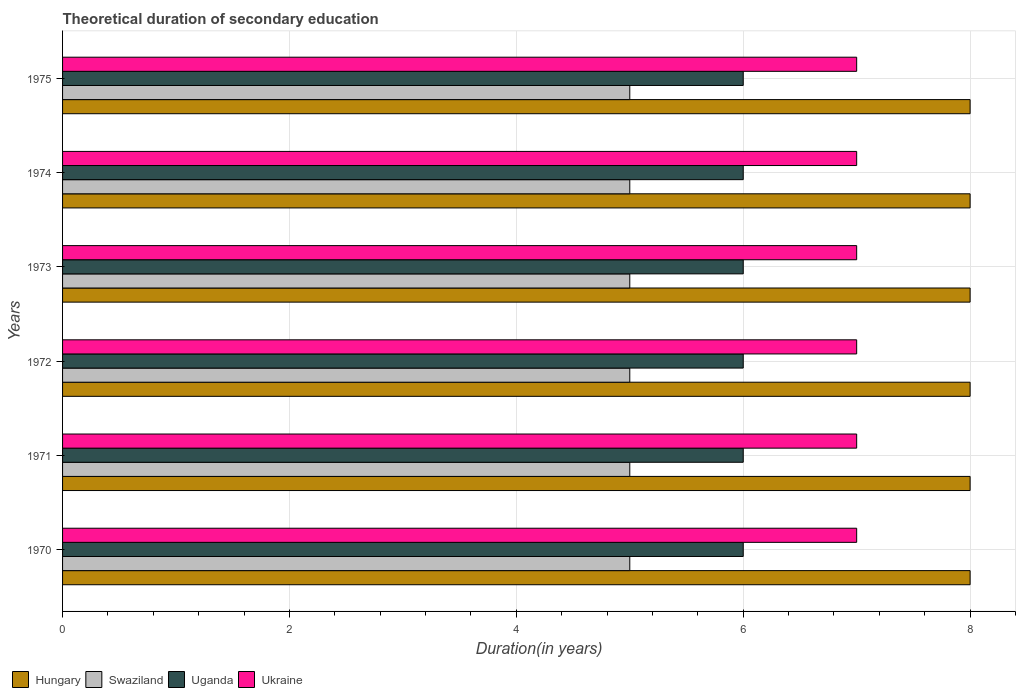How many groups of bars are there?
Your answer should be compact. 6. How many bars are there on the 1st tick from the bottom?
Offer a very short reply. 4. What is the label of the 3rd group of bars from the top?
Make the answer very short. 1973. What is the total theoretical duration of secondary education in Hungary in 1970?
Keep it short and to the point. 8. Across all years, what is the maximum total theoretical duration of secondary education in Swaziland?
Your response must be concise. 5. Across all years, what is the minimum total theoretical duration of secondary education in Swaziland?
Make the answer very short. 5. In which year was the total theoretical duration of secondary education in Swaziland maximum?
Keep it short and to the point. 1970. In which year was the total theoretical duration of secondary education in Uganda minimum?
Keep it short and to the point. 1970. What is the total total theoretical duration of secondary education in Uganda in the graph?
Provide a succinct answer. 36. What is the difference between the total theoretical duration of secondary education in Uganda in 1971 and the total theoretical duration of secondary education in Ukraine in 1972?
Your answer should be compact. -1. In the year 1970, what is the difference between the total theoretical duration of secondary education in Hungary and total theoretical duration of secondary education in Swaziland?
Make the answer very short. 3. In how many years, is the total theoretical duration of secondary education in Swaziland greater than 1.2000000000000002 years?
Ensure brevity in your answer.  6. What is the difference between the highest and the second highest total theoretical duration of secondary education in Swaziland?
Provide a succinct answer. 0. What is the difference between the highest and the lowest total theoretical duration of secondary education in Swaziland?
Your answer should be compact. 0. What does the 1st bar from the top in 1973 represents?
Offer a very short reply. Ukraine. What does the 4th bar from the bottom in 1973 represents?
Offer a very short reply. Ukraine. Are all the bars in the graph horizontal?
Make the answer very short. Yes. How many years are there in the graph?
Your answer should be compact. 6. What is the difference between two consecutive major ticks on the X-axis?
Your response must be concise. 2. Does the graph contain any zero values?
Provide a succinct answer. No. Where does the legend appear in the graph?
Provide a short and direct response. Bottom left. What is the title of the graph?
Offer a terse response. Theoretical duration of secondary education. Does "Morocco" appear as one of the legend labels in the graph?
Your answer should be compact. No. What is the label or title of the X-axis?
Make the answer very short. Duration(in years). What is the Duration(in years) in Hungary in 1970?
Provide a short and direct response. 8. What is the Duration(in years) in Swaziland in 1970?
Your answer should be compact. 5. What is the Duration(in years) in Ukraine in 1970?
Your answer should be compact. 7. What is the Duration(in years) of Hungary in 1971?
Your answer should be compact. 8. What is the Duration(in years) in Ukraine in 1971?
Ensure brevity in your answer.  7. What is the Duration(in years) of Uganda in 1972?
Ensure brevity in your answer.  6. What is the Duration(in years) of Swaziland in 1973?
Provide a succinct answer. 5. What is the Duration(in years) in Uganda in 1973?
Offer a very short reply. 6. What is the Duration(in years) in Hungary in 1974?
Offer a very short reply. 8. What is the Duration(in years) in Uganda in 1974?
Make the answer very short. 6. What is the Duration(in years) in Hungary in 1975?
Ensure brevity in your answer.  8. What is the Duration(in years) of Uganda in 1975?
Make the answer very short. 6. Across all years, what is the maximum Duration(in years) of Hungary?
Provide a succinct answer. 8. Across all years, what is the minimum Duration(in years) in Swaziland?
Your answer should be very brief. 5. Across all years, what is the minimum Duration(in years) of Uganda?
Keep it short and to the point. 6. What is the total Duration(in years) of Hungary in the graph?
Provide a short and direct response. 48. What is the total Duration(in years) in Uganda in the graph?
Your answer should be compact. 36. What is the total Duration(in years) of Ukraine in the graph?
Provide a short and direct response. 42. What is the difference between the Duration(in years) of Hungary in 1970 and that in 1971?
Give a very brief answer. 0. What is the difference between the Duration(in years) of Hungary in 1970 and that in 1972?
Offer a very short reply. 0. What is the difference between the Duration(in years) in Swaziland in 1970 and that in 1972?
Provide a succinct answer. 0. What is the difference between the Duration(in years) in Ukraine in 1970 and that in 1972?
Keep it short and to the point. 0. What is the difference between the Duration(in years) in Hungary in 1970 and that in 1973?
Your answer should be compact. 0. What is the difference between the Duration(in years) in Swaziland in 1970 and that in 1973?
Your answer should be compact. 0. What is the difference between the Duration(in years) in Uganda in 1970 and that in 1973?
Provide a succinct answer. 0. What is the difference between the Duration(in years) of Ukraine in 1970 and that in 1973?
Your answer should be very brief. 0. What is the difference between the Duration(in years) of Hungary in 1970 and that in 1974?
Provide a short and direct response. 0. What is the difference between the Duration(in years) in Swaziland in 1970 and that in 1974?
Your answer should be very brief. 0. What is the difference between the Duration(in years) of Uganda in 1970 and that in 1974?
Ensure brevity in your answer.  0. What is the difference between the Duration(in years) in Hungary in 1971 and that in 1972?
Offer a very short reply. 0. What is the difference between the Duration(in years) of Hungary in 1971 and that in 1973?
Keep it short and to the point. 0. What is the difference between the Duration(in years) of Swaziland in 1971 and that in 1973?
Give a very brief answer. 0. What is the difference between the Duration(in years) of Uganda in 1971 and that in 1973?
Ensure brevity in your answer.  0. What is the difference between the Duration(in years) in Hungary in 1971 and that in 1974?
Provide a succinct answer. 0. What is the difference between the Duration(in years) in Swaziland in 1971 and that in 1974?
Give a very brief answer. 0. What is the difference between the Duration(in years) in Uganda in 1971 and that in 1974?
Ensure brevity in your answer.  0. What is the difference between the Duration(in years) of Ukraine in 1971 and that in 1974?
Give a very brief answer. 0. What is the difference between the Duration(in years) in Uganda in 1972 and that in 1973?
Make the answer very short. 0. What is the difference between the Duration(in years) of Uganda in 1972 and that in 1974?
Make the answer very short. 0. What is the difference between the Duration(in years) in Hungary in 1972 and that in 1975?
Offer a terse response. 0. What is the difference between the Duration(in years) in Swaziland in 1972 and that in 1975?
Give a very brief answer. 0. What is the difference between the Duration(in years) in Uganda in 1972 and that in 1975?
Ensure brevity in your answer.  0. What is the difference between the Duration(in years) of Hungary in 1973 and that in 1974?
Your response must be concise. 0. What is the difference between the Duration(in years) of Swaziland in 1973 and that in 1974?
Provide a succinct answer. 0. What is the difference between the Duration(in years) in Uganda in 1973 and that in 1974?
Offer a very short reply. 0. What is the difference between the Duration(in years) in Hungary in 1973 and that in 1975?
Give a very brief answer. 0. What is the difference between the Duration(in years) in Swaziland in 1973 and that in 1975?
Offer a very short reply. 0. What is the difference between the Duration(in years) in Uganda in 1973 and that in 1975?
Provide a succinct answer. 0. What is the difference between the Duration(in years) of Ukraine in 1973 and that in 1975?
Your answer should be very brief. 0. What is the difference between the Duration(in years) in Swaziland in 1974 and that in 1975?
Provide a succinct answer. 0. What is the difference between the Duration(in years) in Uganda in 1974 and that in 1975?
Your answer should be very brief. 0. What is the difference between the Duration(in years) of Hungary in 1970 and the Duration(in years) of Swaziland in 1971?
Your answer should be very brief. 3. What is the difference between the Duration(in years) in Hungary in 1970 and the Duration(in years) in Uganda in 1971?
Keep it short and to the point. 2. What is the difference between the Duration(in years) of Hungary in 1970 and the Duration(in years) of Ukraine in 1971?
Provide a short and direct response. 1. What is the difference between the Duration(in years) in Swaziland in 1970 and the Duration(in years) in Uganda in 1971?
Your response must be concise. -1. What is the difference between the Duration(in years) of Swaziland in 1970 and the Duration(in years) of Ukraine in 1971?
Your answer should be very brief. -2. What is the difference between the Duration(in years) in Hungary in 1970 and the Duration(in years) in Swaziland in 1972?
Your response must be concise. 3. What is the difference between the Duration(in years) in Hungary in 1970 and the Duration(in years) in Ukraine in 1972?
Your answer should be very brief. 1. What is the difference between the Duration(in years) in Swaziland in 1970 and the Duration(in years) in Uganda in 1972?
Keep it short and to the point. -1. What is the difference between the Duration(in years) in Uganda in 1970 and the Duration(in years) in Ukraine in 1972?
Offer a terse response. -1. What is the difference between the Duration(in years) of Hungary in 1970 and the Duration(in years) of Uganda in 1973?
Ensure brevity in your answer.  2. What is the difference between the Duration(in years) of Hungary in 1970 and the Duration(in years) of Swaziland in 1974?
Offer a very short reply. 3. What is the difference between the Duration(in years) of Hungary in 1970 and the Duration(in years) of Uganda in 1974?
Your answer should be compact. 2. What is the difference between the Duration(in years) in Swaziland in 1970 and the Duration(in years) in Uganda in 1974?
Ensure brevity in your answer.  -1. What is the difference between the Duration(in years) of Hungary in 1970 and the Duration(in years) of Swaziland in 1975?
Your response must be concise. 3. What is the difference between the Duration(in years) of Hungary in 1970 and the Duration(in years) of Ukraine in 1975?
Offer a terse response. 1. What is the difference between the Duration(in years) of Hungary in 1971 and the Duration(in years) of Swaziland in 1972?
Keep it short and to the point. 3. What is the difference between the Duration(in years) in Swaziland in 1971 and the Duration(in years) in Ukraine in 1973?
Make the answer very short. -2. What is the difference between the Duration(in years) of Uganda in 1971 and the Duration(in years) of Ukraine in 1973?
Offer a terse response. -1. What is the difference between the Duration(in years) in Swaziland in 1971 and the Duration(in years) in Uganda in 1974?
Ensure brevity in your answer.  -1. What is the difference between the Duration(in years) of Uganda in 1971 and the Duration(in years) of Ukraine in 1974?
Your response must be concise. -1. What is the difference between the Duration(in years) in Hungary in 1971 and the Duration(in years) in Ukraine in 1975?
Offer a very short reply. 1. What is the difference between the Duration(in years) in Uganda in 1971 and the Duration(in years) in Ukraine in 1975?
Offer a terse response. -1. What is the difference between the Duration(in years) in Hungary in 1972 and the Duration(in years) in Uganda in 1973?
Ensure brevity in your answer.  2. What is the difference between the Duration(in years) of Swaziland in 1972 and the Duration(in years) of Uganda in 1973?
Your answer should be compact. -1. What is the difference between the Duration(in years) of Uganda in 1972 and the Duration(in years) of Ukraine in 1973?
Your response must be concise. -1. What is the difference between the Duration(in years) of Hungary in 1972 and the Duration(in years) of Uganda in 1974?
Your answer should be compact. 2. What is the difference between the Duration(in years) of Hungary in 1972 and the Duration(in years) of Ukraine in 1974?
Your response must be concise. 1. What is the difference between the Duration(in years) of Uganda in 1972 and the Duration(in years) of Ukraine in 1974?
Your answer should be compact. -1. What is the difference between the Duration(in years) in Hungary in 1972 and the Duration(in years) in Ukraine in 1975?
Provide a succinct answer. 1. What is the difference between the Duration(in years) in Hungary in 1973 and the Duration(in years) in Ukraine in 1974?
Provide a short and direct response. 1. What is the difference between the Duration(in years) in Uganda in 1973 and the Duration(in years) in Ukraine in 1974?
Provide a succinct answer. -1. What is the difference between the Duration(in years) of Hungary in 1973 and the Duration(in years) of Swaziland in 1975?
Ensure brevity in your answer.  3. What is the difference between the Duration(in years) in Hungary in 1973 and the Duration(in years) in Uganda in 1975?
Keep it short and to the point. 2. What is the difference between the Duration(in years) in Hungary in 1973 and the Duration(in years) in Ukraine in 1975?
Make the answer very short. 1. What is the difference between the Duration(in years) in Swaziland in 1973 and the Duration(in years) in Uganda in 1975?
Your answer should be compact. -1. What is the difference between the Duration(in years) of Hungary in 1974 and the Duration(in years) of Swaziland in 1975?
Offer a very short reply. 3. What is the difference between the Duration(in years) of Hungary in 1974 and the Duration(in years) of Ukraine in 1975?
Your answer should be very brief. 1. What is the difference between the Duration(in years) in Swaziland in 1974 and the Duration(in years) in Ukraine in 1975?
Your answer should be very brief. -2. What is the average Duration(in years) in Hungary per year?
Provide a succinct answer. 8. What is the average Duration(in years) of Uganda per year?
Your response must be concise. 6. In the year 1970, what is the difference between the Duration(in years) of Hungary and Duration(in years) of Swaziland?
Keep it short and to the point. 3. In the year 1970, what is the difference between the Duration(in years) in Hungary and Duration(in years) in Uganda?
Your response must be concise. 2. In the year 1970, what is the difference between the Duration(in years) in Hungary and Duration(in years) in Ukraine?
Your answer should be compact. 1. In the year 1970, what is the difference between the Duration(in years) of Swaziland and Duration(in years) of Ukraine?
Give a very brief answer. -2. In the year 1970, what is the difference between the Duration(in years) of Uganda and Duration(in years) of Ukraine?
Offer a terse response. -1. In the year 1971, what is the difference between the Duration(in years) of Hungary and Duration(in years) of Swaziland?
Give a very brief answer. 3. In the year 1971, what is the difference between the Duration(in years) in Hungary and Duration(in years) in Uganda?
Your response must be concise. 2. In the year 1971, what is the difference between the Duration(in years) of Uganda and Duration(in years) of Ukraine?
Ensure brevity in your answer.  -1. In the year 1972, what is the difference between the Duration(in years) in Hungary and Duration(in years) in Ukraine?
Your answer should be compact. 1. In the year 1972, what is the difference between the Duration(in years) in Swaziland and Duration(in years) in Ukraine?
Your answer should be very brief. -2. In the year 1972, what is the difference between the Duration(in years) of Uganda and Duration(in years) of Ukraine?
Give a very brief answer. -1. In the year 1973, what is the difference between the Duration(in years) in Hungary and Duration(in years) in Swaziland?
Ensure brevity in your answer.  3. In the year 1973, what is the difference between the Duration(in years) of Hungary and Duration(in years) of Uganda?
Offer a terse response. 2. In the year 1973, what is the difference between the Duration(in years) of Hungary and Duration(in years) of Ukraine?
Ensure brevity in your answer.  1. In the year 1973, what is the difference between the Duration(in years) in Swaziland and Duration(in years) in Uganda?
Offer a terse response. -1. In the year 1973, what is the difference between the Duration(in years) in Swaziland and Duration(in years) in Ukraine?
Offer a very short reply. -2. In the year 1973, what is the difference between the Duration(in years) in Uganda and Duration(in years) in Ukraine?
Provide a succinct answer. -1. In the year 1974, what is the difference between the Duration(in years) in Hungary and Duration(in years) in Swaziland?
Keep it short and to the point. 3. In the year 1974, what is the difference between the Duration(in years) in Hungary and Duration(in years) in Uganda?
Offer a terse response. 2. In the year 1974, what is the difference between the Duration(in years) of Hungary and Duration(in years) of Ukraine?
Your answer should be compact. 1. In the year 1974, what is the difference between the Duration(in years) of Swaziland and Duration(in years) of Uganda?
Ensure brevity in your answer.  -1. In the year 1974, what is the difference between the Duration(in years) of Uganda and Duration(in years) of Ukraine?
Keep it short and to the point. -1. In the year 1975, what is the difference between the Duration(in years) of Hungary and Duration(in years) of Ukraine?
Offer a very short reply. 1. In the year 1975, what is the difference between the Duration(in years) in Swaziland and Duration(in years) in Uganda?
Ensure brevity in your answer.  -1. In the year 1975, what is the difference between the Duration(in years) of Uganda and Duration(in years) of Ukraine?
Offer a very short reply. -1. What is the ratio of the Duration(in years) in Hungary in 1970 to that in 1971?
Keep it short and to the point. 1. What is the ratio of the Duration(in years) in Uganda in 1970 to that in 1971?
Your response must be concise. 1. What is the ratio of the Duration(in years) in Swaziland in 1970 to that in 1972?
Keep it short and to the point. 1. What is the ratio of the Duration(in years) of Uganda in 1970 to that in 1972?
Provide a succinct answer. 1. What is the ratio of the Duration(in years) in Ukraine in 1970 to that in 1972?
Offer a terse response. 1. What is the ratio of the Duration(in years) of Hungary in 1970 to that in 1974?
Your answer should be very brief. 1. What is the ratio of the Duration(in years) in Hungary in 1970 to that in 1975?
Your response must be concise. 1. What is the ratio of the Duration(in years) of Uganda in 1970 to that in 1975?
Offer a terse response. 1. What is the ratio of the Duration(in years) in Ukraine in 1970 to that in 1975?
Ensure brevity in your answer.  1. What is the ratio of the Duration(in years) of Uganda in 1971 to that in 1972?
Offer a very short reply. 1. What is the ratio of the Duration(in years) of Swaziland in 1971 to that in 1973?
Keep it short and to the point. 1. What is the ratio of the Duration(in years) in Ukraine in 1971 to that in 1973?
Make the answer very short. 1. What is the ratio of the Duration(in years) in Uganda in 1971 to that in 1974?
Keep it short and to the point. 1. What is the ratio of the Duration(in years) of Ukraine in 1971 to that in 1974?
Give a very brief answer. 1. What is the ratio of the Duration(in years) of Swaziland in 1971 to that in 1975?
Your answer should be compact. 1. What is the ratio of the Duration(in years) of Uganda in 1971 to that in 1975?
Provide a short and direct response. 1. What is the ratio of the Duration(in years) of Ukraine in 1971 to that in 1975?
Give a very brief answer. 1. What is the ratio of the Duration(in years) of Swaziland in 1972 to that in 1973?
Keep it short and to the point. 1. What is the ratio of the Duration(in years) of Ukraine in 1972 to that in 1973?
Your response must be concise. 1. What is the ratio of the Duration(in years) of Swaziland in 1972 to that in 1974?
Your answer should be compact. 1. What is the ratio of the Duration(in years) of Hungary in 1972 to that in 1975?
Your answer should be very brief. 1. What is the ratio of the Duration(in years) in Uganda in 1972 to that in 1975?
Keep it short and to the point. 1. What is the ratio of the Duration(in years) of Ukraine in 1972 to that in 1975?
Give a very brief answer. 1. What is the ratio of the Duration(in years) of Hungary in 1973 to that in 1974?
Offer a terse response. 1. What is the ratio of the Duration(in years) in Swaziland in 1973 to that in 1975?
Give a very brief answer. 1. What is the ratio of the Duration(in years) of Uganda in 1973 to that in 1975?
Ensure brevity in your answer.  1. What is the ratio of the Duration(in years) in Ukraine in 1973 to that in 1975?
Offer a terse response. 1. What is the ratio of the Duration(in years) in Hungary in 1974 to that in 1975?
Provide a short and direct response. 1. What is the difference between the highest and the second highest Duration(in years) of Hungary?
Keep it short and to the point. 0. What is the difference between the highest and the second highest Duration(in years) in Uganda?
Offer a very short reply. 0. What is the difference between the highest and the second highest Duration(in years) of Ukraine?
Ensure brevity in your answer.  0. What is the difference between the highest and the lowest Duration(in years) of Uganda?
Give a very brief answer. 0. 